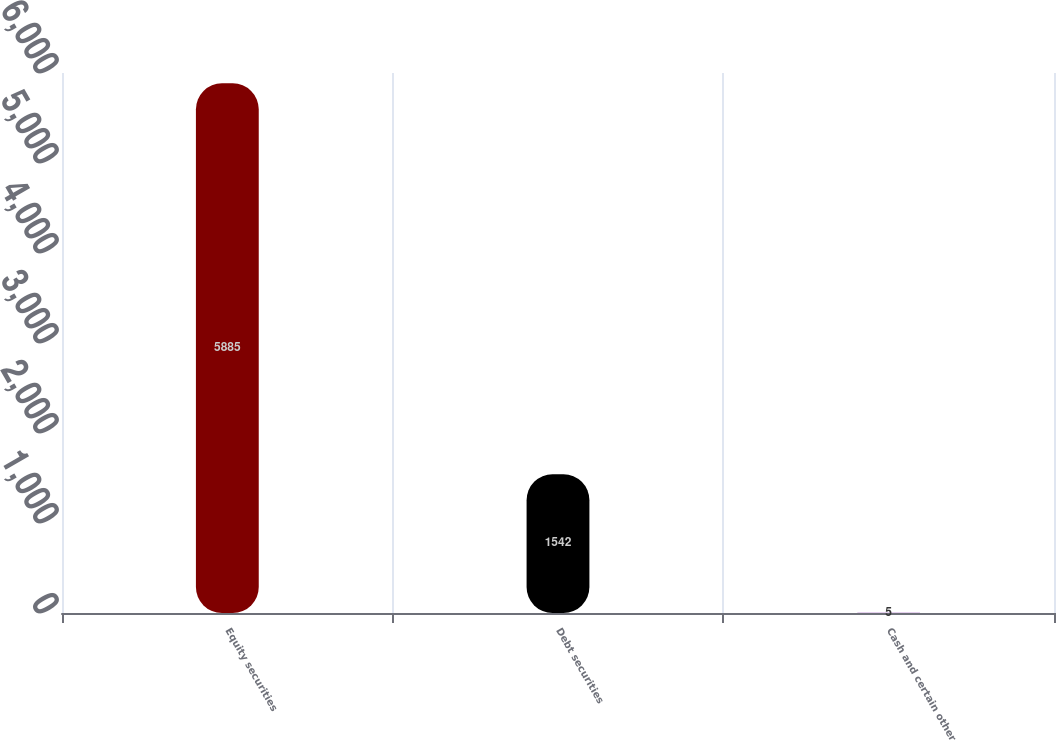Convert chart to OTSL. <chart><loc_0><loc_0><loc_500><loc_500><bar_chart><fcel>Equity securities<fcel>Debt securities<fcel>Cash and certain other<nl><fcel>5885<fcel>1542<fcel>5<nl></chart> 